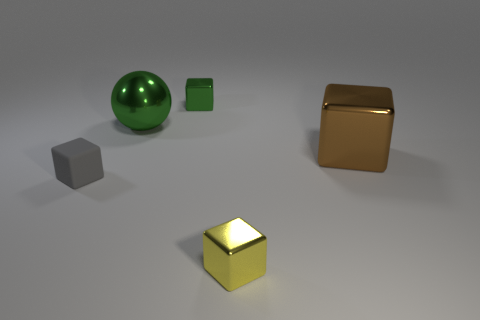What is the shape of the large object that is on the left side of the metallic thing in front of the large brown metallic cube?
Make the answer very short. Sphere. Is there anything else of the same color as the big metallic sphere?
Your answer should be very brief. Yes. How many things are either big purple cylinders or metal blocks?
Offer a terse response. 3. Are there any other gray metallic spheres of the same size as the metal sphere?
Offer a very short reply. No. The brown metallic object has what shape?
Make the answer very short. Cube. Is the number of green balls that are in front of the big green thing greater than the number of gray things that are in front of the small yellow metal cube?
Your answer should be compact. No. There is a big object that is on the right side of the large green metal thing; is its color the same as the small shiny thing in front of the big brown metal object?
Give a very brief answer. No. What shape is the yellow object that is the same size as the gray object?
Make the answer very short. Cube. Are there any other tiny yellow metal things that have the same shape as the small yellow thing?
Make the answer very short. No. Does the green thing that is behind the big green ball have the same material as the cube on the right side of the yellow block?
Keep it short and to the point. Yes. 